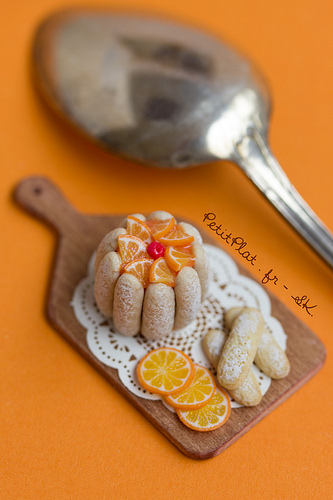<image>
Can you confirm if the snacks is next to the spoon? Yes. The snacks is positioned adjacent to the spoon, located nearby in the same general area. 